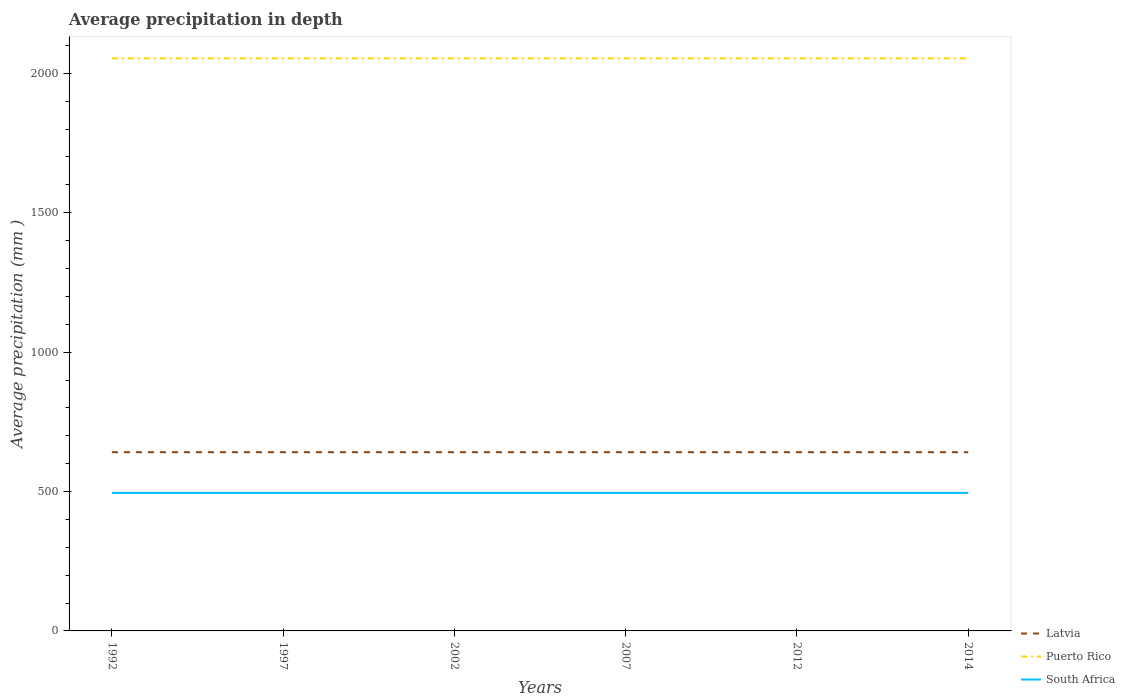Does the line corresponding to Puerto Rico intersect with the line corresponding to South Africa?
Make the answer very short. No. Is the number of lines equal to the number of legend labels?
Your answer should be compact. Yes. Across all years, what is the maximum average precipitation in Puerto Rico?
Make the answer very short. 2054. In which year was the average precipitation in South Africa maximum?
Ensure brevity in your answer.  1992. What is the difference between the highest and the lowest average precipitation in Latvia?
Your answer should be very brief. 0. How many lines are there?
Ensure brevity in your answer.  3. What is the difference between two consecutive major ticks on the Y-axis?
Make the answer very short. 500. Are the values on the major ticks of Y-axis written in scientific E-notation?
Your response must be concise. No. How many legend labels are there?
Keep it short and to the point. 3. What is the title of the graph?
Provide a short and direct response. Average precipitation in depth. Does "Bermuda" appear as one of the legend labels in the graph?
Keep it short and to the point. No. What is the label or title of the X-axis?
Your answer should be compact. Years. What is the label or title of the Y-axis?
Your response must be concise. Average precipitation (mm ). What is the Average precipitation (mm ) of Latvia in 1992?
Offer a very short reply. 641. What is the Average precipitation (mm ) of Puerto Rico in 1992?
Your answer should be compact. 2054. What is the Average precipitation (mm ) in South Africa in 1992?
Ensure brevity in your answer.  495. What is the Average precipitation (mm ) in Latvia in 1997?
Your answer should be compact. 641. What is the Average precipitation (mm ) in Puerto Rico in 1997?
Make the answer very short. 2054. What is the Average precipitation (mm ) in South Africa in 1997?
Provide a succinct answer. 495. What is the Average precipitation (mm ) of Latvia in 2002?
Provide a succinct answer. 641. What is the Average precipitation (mm ) in Puerto Rico in 2002?
Offer a terse response. 2054. What is the Average precipitation (mm ) in South Africa in 2002?
Your answer should be compact. 495. What is the Average precipitation (mm ) of Latvia in 2007?
Your answer should be compact. 641. What is the Average precipitation (mm ) in Puerto Rico in 2007?
Provide a short and direct response. 2054. What is the Average precipitation (mm ) in South Africa in 2007?
Give a very brief answer. 495. What is the Average precipitation (mm ) in Latvia in 2012?
Offer a very short reply. 641. What is the Average precipitation (mm ) of Puerto Rico in 2012?
Your answer should be very brief. 2054. What is the Average precipitation (mm ) in South Africa in 2012?
Your answer should be compact. 495. What is the Average precipitation (mm ) of Latvia in 2014?
Make the answer very short. 641. What is the Average precipitation (mm ) in Puerto Rico in 2014?
Give a very brief answer. 2054. What is the Average precipitation (mm ) of South Africa in 2014?
Your answer should be compact. 495. Across all years, what is the maximum Average precipitation (mm ) of Latvia?
Your answer should be compact. 641. Across all years, what is the maximum Average precipitation (mm ) in Puerto Rico?
Provide a short and direct response. 2054. Across all years, what is the maximum Average precipitation (mm ) of South Africa?
Offer a terse response. 495. Across all years, what is the minimum Average precipitation (mm ) in Latvia?
Keep it short and to the point. 641. Across all years, what is the minimum Average precipitation (mm ) in Puerto Rico?
Ensure brevity in your answer.  2054. Across all years, what is the minimum Average precipitation (mm ) in South Africa?
Your answer should be very brief. 495. What is the total Average precipitation (mm ) of Latvia in the graph?
Offer a terse response. 3846. What is the total Average precipitation (mm ) of Puerto Rico in the graph?
Offer a very short reply. 1.23e+04. What is the total Average precipitation (mm ) of South Africa in the graph?
Provide a succinct answer. 2970. What is the difference between the Average precipitation (mm ) in Puerto Rico in 1992 and that in 2002?
Your response must be concise. 0. What is the difference between the Average precipitation (mm ) in Puerto Rico in 1992 and that in 2007?
Give a very brief answer. 0. What is the difference between the Average precipitation (mm ) of Latvia in 1992 and that in 2012?
Offer a terse response. 0. What is the difference between the Average precipitation (mm ) in Puerto Rico in 1992 and that in 2012?
Offer a very short reply. 0. What is the difference between the Average precipitation (mm ) in South Africa in 1992 and that in 2012?
Offer a very short reply. 0. What is the difference between the Average precipitation (mm ) in Latvia in 1992 and that in 2014?
Offer a terse response. 0. What is the difference between the Average precipitation (mm ) in South Africa in 1992 and that in 2014?
Offer a very short reply. 0. What is the difference between the Average precipitation (mm ) of Latvia in 1997 and that in 2002?
Offer a terse response. 0. What is the difference between the Average precipitation (mm ) in South Africa in 1997 and that in 2002?
Give a very brief answer. 0. What is the difference between the Average precipitation (mm ) in South Africa in 1997 and that in 2007?
Your response must be concise. 0. What is the difference between the Average precipitation (mm ) of Latvia in 1997 and that in 2014?
Make the answer very short. 0. What is the difference between the Average precipitation (mm ) of Puerto Rico in 1997 and that in 2014?
Offer a terse response. 0. What is the difference between the Average precipitation (mm ) in South Africa in 1997 and that in 2014?
Provide a short and direct response. 0. What is the difference between the Average precipitation (mm ) in Puerto Rico in 2002 and that in 2007?
Offer a very short reply. 0. What is the difference between the Average precipitation (mm ) of South Africa in 2002 and that in 2007?
Your answer should be very brief. 0. What is the difference between the Average precipitation (mm ) of Puerto Rico in 2002 and that in 2012?
Offer a very short reply. 0. What is the difference between the Average precipitation (mm ) in South Africa in 2002 and that in 2012?
Ensure brevity in your answer.  0. What is the difference between the Average precipitation (mm ) of Latvia in 2002 and that in 2014?
Ensure brevity in your answer.  0. What is the difference between the Average precipitation (mm ) of Puerto Rico in 2002 and that in 2014?
Offer a terse response. 0. What is the difference between the Average precipitation (mm ) of South Africa in 2002 and that in 2014?
Your answer should be compact. 0. What is the difference between the Average precipitation (mm ) of Puerto Rico in 2007 and that in 2012?
Ensure brevity in your answer.  0. What is the difference between the Average precipitation (mm ) of Latvia in 2007 and that in 2014?
Your answer should be compact. 0. What is the difference between the Average precipitation (mm ) of Puerto Rico in 2007 and that in 2014?
Keep it short and to the point. 0. What is the difference between the Average precipitation (mm ) in Latvia in 1992 and the Average precipitation (mm ) in Puerto Rico in 1997?
Make the answer very short. -1413. What is the difference between the Average precipitation (mm ) of Latvia in 1992 and the Average precipitation (mm ) of South Africa in 1997?
Offer a terse response. 146. What is the difference between the Average precipitation (mm ) of Puerto Rico in 1992 and the Average precipitation (mm ) of South Africa in 1997?
Keep it short and to the point. 1559. What is the difference between the Average precipitation (mm ) in Latvia in 1992 and the Average precipitation (mm ) in Puerto Rico in 2002?
Make the answer very short. -1413. What is the difference between the Average precipitation (mm ) of Latvia in 1992 and the Average precipitation (mm ) of South Africa in 2002?
Provide a succinct answer. 146. What is the difference between the Average precipitation (mm ) in Puerto Rico in 1992 and the Average precipitation (mm ) in South Africa in 2002?
Your response must be concise. 1559. What is the difference between the Average precipitation (mm ) of Latvia in 1992 and the Average precipitation (mm ) of Puerto Rico in 2007?
Your answer should be very brief. -1413. What is the difference between the Average precipitation (mm ) in Latvia in 1992 and the Average precipitation (mm ) in South Africa in 2007?
Offer a very short reply. 146. What is the difference between the Average precipitation (mm ) of Puerto Rico in 1992 and the Average precipitation (mm ) of South Africa in 2007?
Keep it short and to the point. 1559. What is the difference between the Average precipitation (mm ) in Latvia in 1992 and the Average precipitation (mm ) in Puerto Rico in 2012?
Provide a succinct answer. -1413. What is the difference between the Average precipitation (mm ) in Latvia in 1992 and the Average precipitation (mm ) in South Africa in 2012?
Make the answer very short. 146. What is the difference between the Average precipitation (mm ) of Puerto Rico in 1992 and the Average precipitation (mm ) of South Africa in 2012?
Keep it short and to the point. 1559. What is the difference between the Average precipitation (mm ) of Latvia in 1992 and the Average precipitation (mm ) of Puerto Rico in 2014?
Give a very brief answer. -1413. What is the difference between the Average precipitation (mm ) of Latvia in 1992 and the Average precipitation (mm ) of South Africa in 2014?
Ensure brevity in your answer.  146. What is the difference between the Average precipitation (mm ) in Puerto Rico in 1992 and the Average precipitation (mm ) in South Africa in 2014?
Your answer should be very brief. 1559. What is the difference between the Average precipitation (mm ) of Latvia in 1997 and the Average precipitation (mm ) of Puerto Rico in 2002?
Offer a terse response. -1413. What is the difference between the Average precipitation (mm ) of Latvia in 1997 and the Average precipitation (mm ) of South Africa in 2002?
Give a very brief answer. 146. What is the difference between the Average precipitation (mm ) of Puerto Rico in 1997 and the Average precipitation (mm ) of South Africa in 2002?
Your answer should be compact. 1559. What is the difference between the Average precipitation (mm ) in Latvia in 1997 and the Average precipitation (mm ) in Puerto Rico in 2007?
Make the answer very short. -1413. What is the difference between the Average precipitation (mm ) in Latvia in 1997 and the Average precipitation (mm ) in South Africa in 2007?
Provide a short and direct response. 146. What is the difference between the Average precipitation (mm ) of Puerto Rico in 1997 and the Average precipitation (mm ) of South Africa in 2007?
Offer a terse response. 1559. What is the difference between the Average precipitation (mm ) of Latvia in 1997 and the Average precipitation (mm ) of Puerto Rico in 2012?
Provide a succinct answer. -1413. What is the difference between the Average precipitation (mm ) in Latvia in 1997 and the Average precipitation (mm ) in South Africa in 2012?
Make the answer very short. 146. What is the difference between the Average precipitation (mm ) of Puerto Rico in 1997 and the Average precipitation (mm ) of South Africa in 2012?
Provide a short and direct response. 1559. What is the difference between the Average precipitation (mm ) in Latvia in 1997 and the Average precipitation (mm ) in Puerto Rico in 2014?
Offer a terse response. -1413. What is the difference between the Average precipitation (mm ) of Latvia in 1997 and the Average precipitation (mm ) of South Africa in 2014?
Provide a short and direct response. 146. What is the difference between the Average precipitation (mm ) of Puerto Rico in 1997 and the Average precipitation (mm ) of South Africa in 2014?
Give a very brief answer. 1559. What is the difference between the Average precipitation (mm ) of Latvia in 2002 and the Average precipitation (mm ) of Puerto Rico in 2007?
Your answer should be compact. -1413. What is the difference between the Average precipitation (mm ) in Latvia in 2002 and the Average precipitation (mm ) in South Africa in 2007?
Offer a terse response. 146. What is the difference between the Average precipitation (mm ) of Puerto Rico in 2002 and the Average precipitation (mm ) of South Africa in 2007?
Ensure brevity in your answer.  1559. What is the difference between the Average precipitation (mm ) of Latvia in 2002 and the Average precipitation (mm ) of Puerto Rico in 2012?
Offer a terse response. -1413. What is the difference between the Average precipitation (mm ) in Latvia in 2002 and the Average precipitation (mm ) in South Africa in 2012?
Offer a terse response. 146. What is the difference between the Average precipitation (mm ) in Puerto Rico in 2002 and the Average precipitation (mm ) in South Africa in 2012?
Provide a short and direct response. 1559. What is the difference between the Average precipitation (mm ) in Latvia in 2002 and the Average precipitation (mm ) in Puerto Rico in 2014?
Your answer should be very brief. -1413. What is the difference between the Average precipitation (mm ) in Latvia in 2002 and the Average precipitation (mm ) in South Africa in 2014?
Give a very brief answer. 146. What is the difference between the Average precipitation (mm ) of Puerto Rico in 2002 and the Average precipitation (mm ) of South Africa in 2014?
Provide a succinct answer. 1559. What is the difference between the Average precipitation (mm ) in Latvia in 2007 and the Average precipitation (mm ) in Puerto Rico in 2012?
Your response must be concise. -1413. What is the difference between the Average precipitation (mm ) of Latvia in 2007 and the Average precipitation (mm ) of South Africa in 2012?
Keep it short and to the point. 146. What is the difference between the Average precipitation (mm ) of Puerto Rico in 2007 and the Average precipitation (mm ) of South Africa in 2012?
Offer a very short reply. 1559. What is the difference between the Average precipitation (mm ) in Latvia in 2007 and the Average precipitation (mm ) in Puerto Rico in 2014?
Provide a short and direct response. -1413. What is the difference between the Average precipitation (mm ) of Latvia in 2007 and the Average precipitation (mm ) of South Africa in 2014?
Your answer should be compact. 146. What is the difference between the Average precipitation (mm ) in Puerto Rico in 2007 and the Average precipitation (mm ) in South Africa in 2014?
Keep it short and to the point. 1559. What is the difference between the Average precipitation (mm ) of Latvia in 2012 and the Average precipitation (mm ) of Puerto Rico in 2014?
Offer a very short reply. -1413. What is the difference between the Average precipitation (mm ) of Latvia in 2012 and the Average precipitation (mm ) of South Africa in 2014?
Give a very brief answer. 146. What is the difference between the Average precipitation (mm ) in Puerto Rico in 2012 and the Average precipitation (mm ) in South Africa in 2014?
Provide a succinct answer. 1559. What is the average Average precipitation (mm ) of Latvia per year?
Your answer should be compact. 641. What is the average Average precipitation (mm ) of Puerto Rico per year?
Ensure brevity in your answer.  2054. What is the average Average precipitation (mm ) in South Africa per year?
Give a very brief answer. 495. In the year 1992, what is the difference between the Average precipitation (mm ) in Latvia and Average precipitation (mm ) in Puerto Rico?
Offer a very short reply. -1413. In the year 1992, what is the difference between the Average precipitation (mm ) in Latvia and Average precipitation (mm ) in South Africa?
Ensure brevity in your answer.  146. In the year 1992, what is the difference between the Average precipitation (mm ) in Puerto Rico and Average precipitation (mm ) in South Africa?
Keep it short and to the point. 1559. In the year 1997, what is the difference between the Average precipitation (mm ) in Latvia and Average precipitation (mm ) in Puerto Rico?
Offer a terse response. -1413. In the year 1997, what is the difference between the Average precipitation (mm ) in Latvia and Average precipitation (mm ) in South Africa?
Offer a very short reply. 146. In the year 1997, what is the difference between the Average precipitation (mm ) in Puerto Rico and Average precipitation (mm ) in South Africa?
Offer a terse response. 1559. In the year 2002, what is the difference between the Average precipitation (mm ) in Latvia and Average precipitation (mm ) in Puerto Rico?
Give a very brief answer. -1413. In the year 2002, what is the difference between the Average precipitation (mm ) in Latvia and Average precipitation (mm ) in South Africa?
Make the answer very short. 146. In the year 2002, what is the difference between the Average precipitation (mm ) of Puerto Rico and Average precipitation (mm ) of South Africa?
Ensure brevity in your answer.  1559. In the year 2007, what is the difference between the Average precipitation (mm ) of Latvia and Average precipitation (mm ) of Puerto Rico?
Provide a short and direct response. -1413. In the year 2007, what is the difference between the Average precipitation (mm ) in Latvia and Average precipitation (mm ) in South Africa?
Your answer should be compact. 146. In the year 2007, what is the difference between the Average precipitation (mm ) in Puerto Rico and Average precipitation (mm ) in South Africa?
Offer a terse response. 1559. In the year 2012, what is the difference between the Average precipitation (mm ) in Latvia and Average precipitation (mm ) in Puerto Rico?
Your answer should be compact. -1413. In the year 2012, what is the difference between the Average precipitation (mm ) in Latvia and Average precipitation (mm ) in South Africa?
Your answer should be compact. 146. In the year 2012, what is the difference between the Average precipitation (mm ) in Puerto Rico and Average precipitation (mm ) in South Africa?
Ensure brevity in your answer.  1559. In the year 2014, what is the difference between the Average precipitation (mm ) in Latvia and Average precipitation (mm ) in Puerto Rico?
Offer a terse response. -1413. In the year 2014, what is the difference between the Average precipitation (mm ) of Latvia and Average precipitation (mm ) of South Africa?
Your answer should be compact. 146. In the year 2014, what is the difference between the Average precipitation (mm ) of Puerto Rico and Average precipitation (mm ) of South Africa?
Make the answer very short. 1559. What is the ratio of the Average precipitation (mm ) in Latvia in 1992 to that in 2002?
Ensure brevity in your answer.  1. What is the ratio of the Average precipitation (mm ) of Puerto Rico in 1992 to that in 2002?
Make the answer very short. 1. What is the ratio of the Average precipitation (mm ) in South Africa in 1992 to that in 2002?
Keep it short and to the point. 1. What is the ratio of the Average precipitation (mm ) in Puerto Rico in 1992 to that in 2007?
Your answer should be compact. 1. What is the ratio of the Average precipitation (mm ) in South Africa in 1992 to that in 2007?
Your response must be concise. 1. What is the ratio of the Average precipitation (mm ) in South Africa in 1992 to that in 2012?
Give a very brief answer. 1. What is the ratio of the Average precipitation (mm ) of Puerto Rico in 1992 to that in 2014?
Your answer should be very brief. 1. What is the ratio of the Average precipitation (mm ) of South Africa in 1992 to that in 2014?
Make the answer very short. 1. What is the ratio of the Average precipitation (mm ) of Latvia in 1997 to that in 2007?
Your answer should be compact. 1. What is the ratio of the Average precipitation (mm ) in Puerto Rico in 1997 to that in 2007?
Make the answer very short. 1. What is the ratio of the Average precipitation (mm ) in South Africa in 1997 to that in 2007?
Give a very brief answer. 1. What is the ratio of the Average precipitation (mm ) of Latvia in 1997 to that in 2012?
Your response must be concise. 1. What is the ratio of the Average precipitation (mm ) of Puerto Rico in 1997 to that in 2014?
Provide a short and direct response. 1. What is the ratio of the Average precipitation (mm ) in Latvia in 2002 to that in 2007?
Ensure brevity in your answer.  1. What is the ratio of the Average precipitation (mm ) in Latvia in 2002 to that in 2012?
Offer a terse response. 1. What is the ratio of the Average precipitation (mm ) in South Africa in 2002 to that in 2012?
Your answer should be very brief. 1. What is the ratio of the Average precipitation (mm ) of Latvia in 2002 to that in 2014?
Provide a short and direct response. 1. What is the ratio of the Average precipitation (mm ) in South Africa in 2002 to that in 2014?
Provide a succinct answer. 1. What is the ratio of the Average precipitation (mm ) in Latvia in 2007 to that in 2012?
Your response must be concise. 1. What is the ratio of the Average precipitation (mm ) of Latvia in 2007 to that in 2014?
Your answer should be compact. 1. What is the ratio of the Average precipitation (mm ) in Puerto Rico in 2007 to that in 2014?
Your response must be concise. 1. What is the ratio of the Average precipitation (mm ) in Latvia in 2012 to that in 2014?
Provide a short and direct response. 1. What is the ratio of the Average precipitation (mm ) of Puerto Rico in 2012 to that in 2014?
Keep it short and to the point. 1. What is the difference between the highest and the second highest Average precipitation (mm ) of Latvia?
Ensure brevity in your answer.  0. What is the difference between the highest and the second highest Average precipitation (mm ) of Puerto Rico?
Provide a short and direct response. 0. What is the difference between the highest and the lowest Average precipitation (mm ) in Latvia?
Your answer should be compact. 0. What is the difference between the highest and the lowest Average precipitation (mm ) of Puerto Rico?
Provide a succinct answer. 0. 